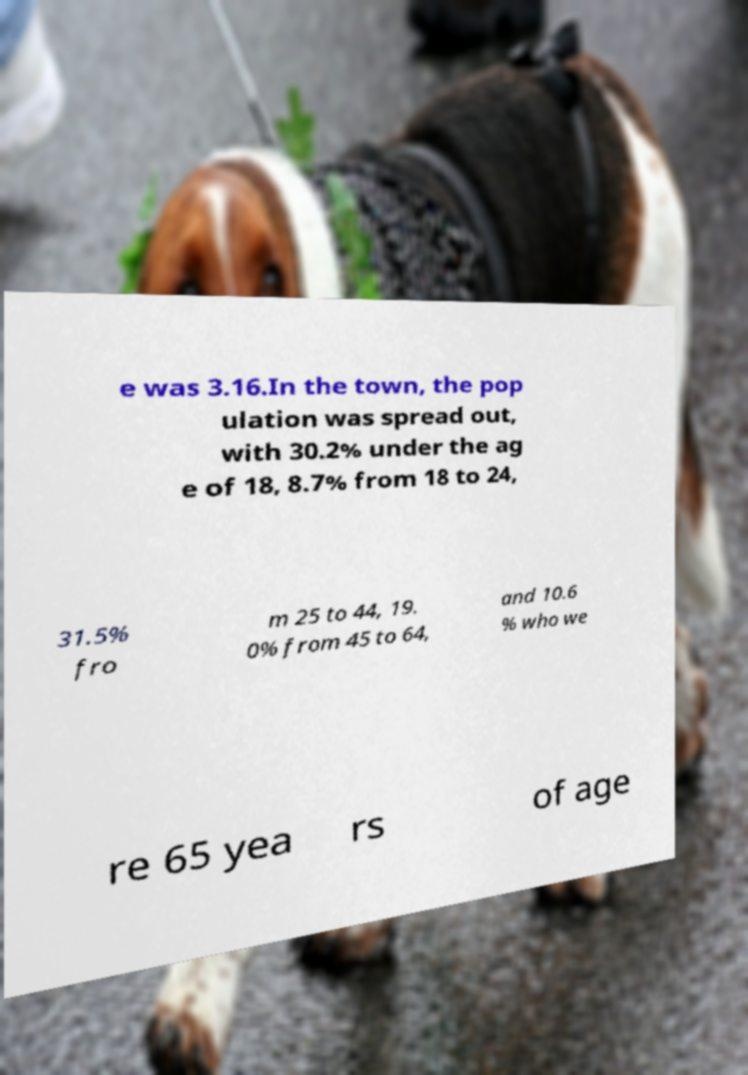Can you accurately transcribe the text from the provided image for me? e was 3.16.In the town, the pop ulation was spread out, with 30.2% under the ag e of 18, 8.7% from 18 to 24, 31.5% fro m 25 to 44, 19. 0% from 45 to 64, and 10.6 % who we re 65 yea rs of age 